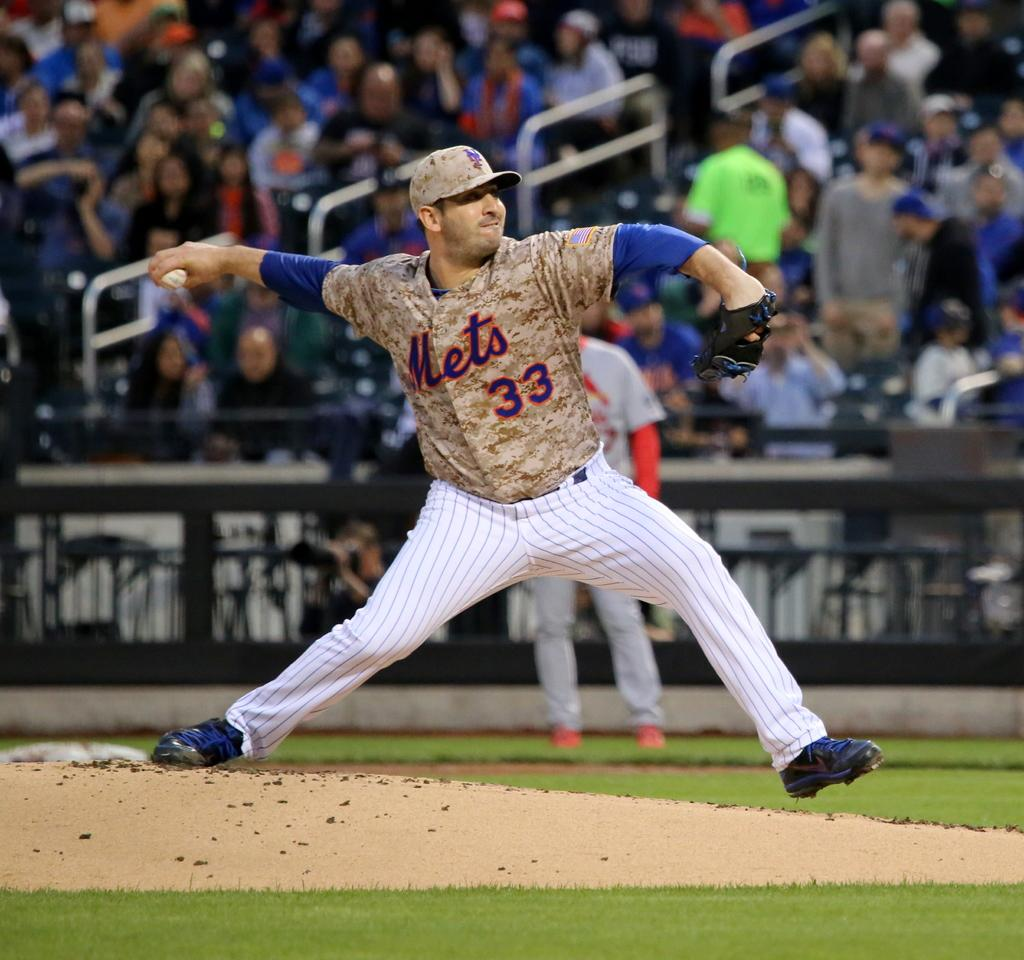<image>
Describe the image concisely. Number 33, Mets is the designation of the player on the mound. 